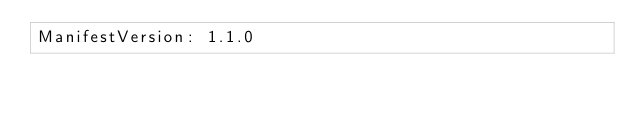<code> <loc_0><loc_0><loc_500><loc_500><_YAML_>ManifestVersion: 1.1.0
</code> 